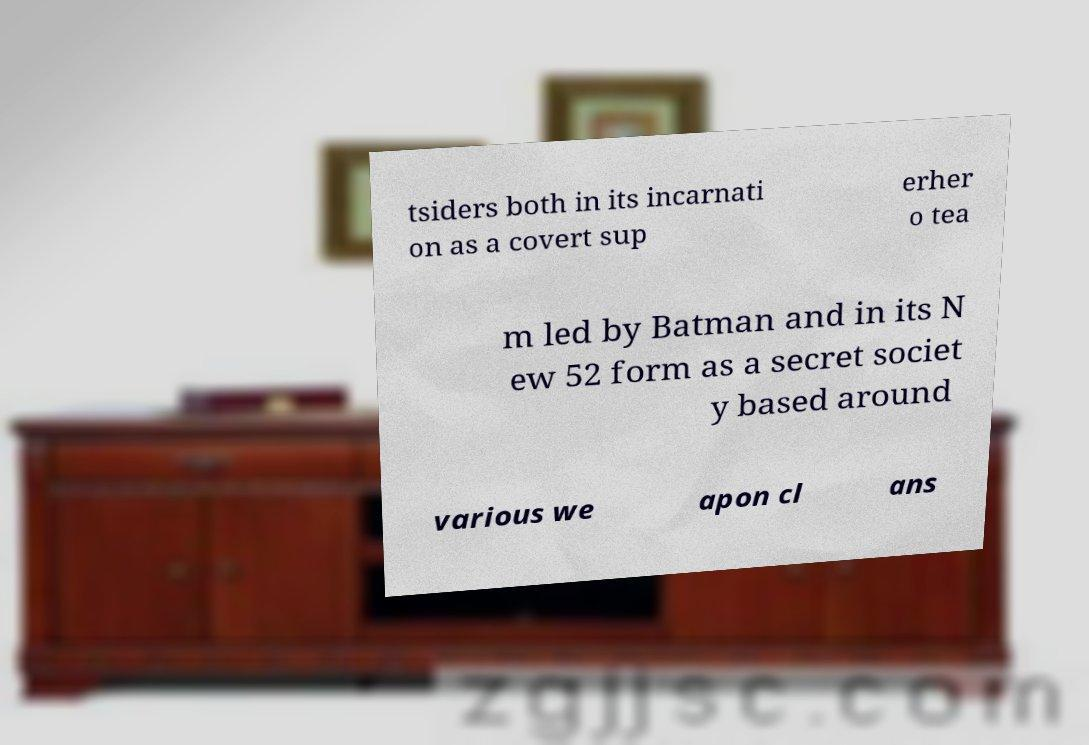Could you extract and type out the text from this image? tsiders both in its incarnati on as a covert sup erher o tea m led by Batman and in its N ew 52 form as a secret societ y based around various we apon cl ans 